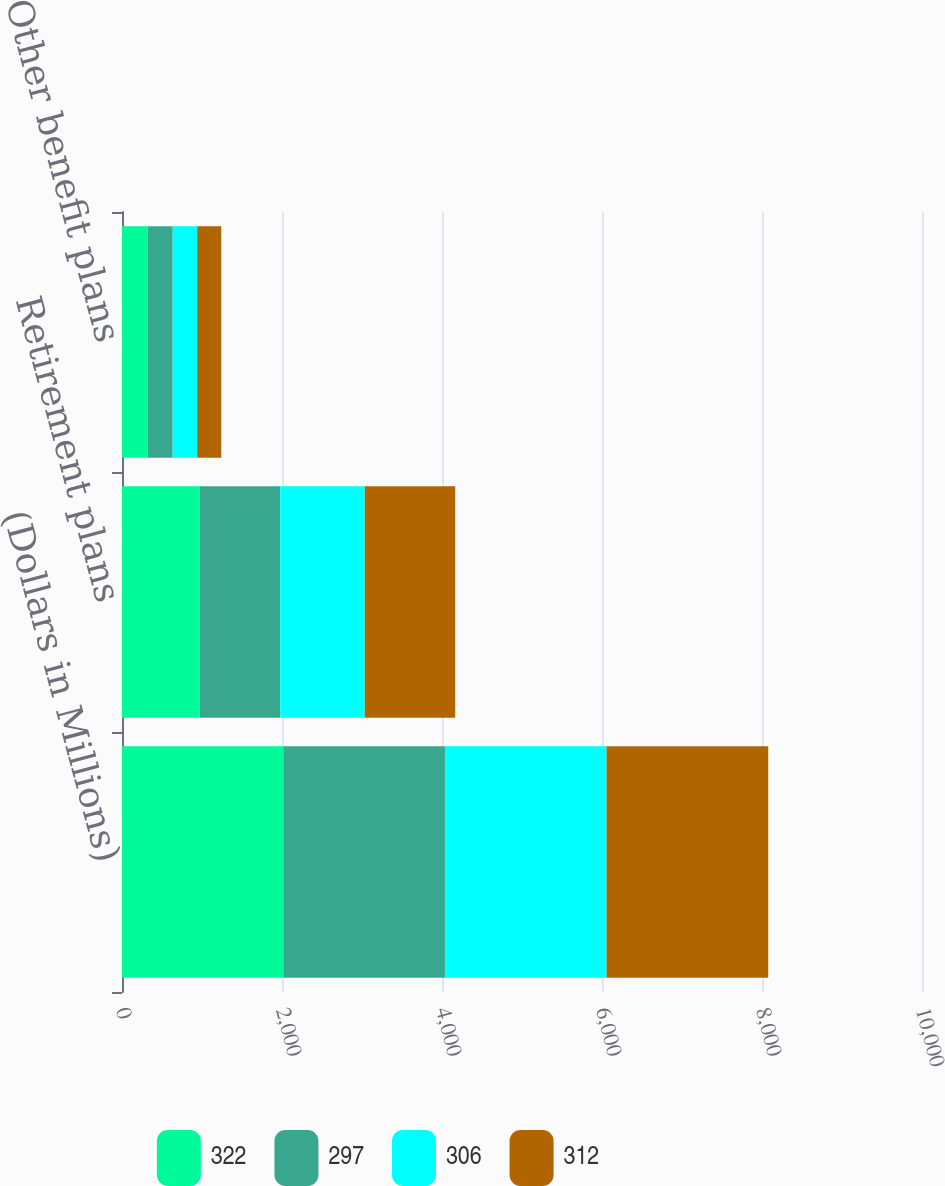Convert chart to OTSL. <chart><loc_0><loc_0><loc_500><loc_500><stacked_bar_chart><ecel><fcel>(Dollars in Millions)<fcel>Retirement plans<fcel>Other benefit plans<nl><fcel>322<fcel>2018<fcel>970<fcel>322<nl><fcel>297<fcel>2019<fcel>1007<fcel>312<nl><fcel>306<fcel>2020<fcel>1057<fcel>306<nl><fcel>312<fcel>2021<fcel>1131<fcel>301<nl></chart> 